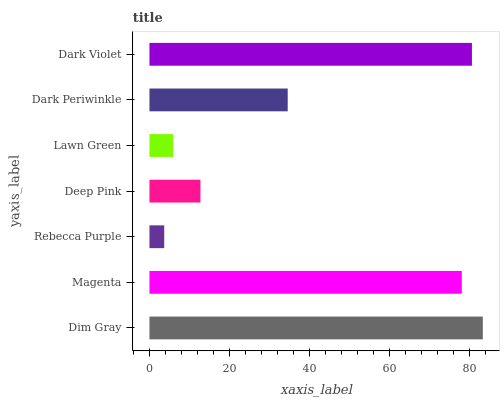Is Rebecca Purple the minimum?
Answer yes or no. Yes. Is Dim Gray the maximum?
Answer yes or no. Yes. Is Magenta the minimum?
Answer yes or no. No. Is Magenta the maximum?
Answer yes or no. No. Is Dim Gray greater than Magenta?
Answer yes or no. Yes. Is Magenta less than Dim Gray?
Answer yes or no. Yes. Is Magenta greater than Dim Gray?
Answer yes or no. No. Is Dim Gray less than Magenta?
Answer yes or no. No. Is Dark Periwinkle the high median?
Answer yes or no. Yes. Is Dark Periwinkle the low median?
Answer yes or no. Yes. Is Lawn Green the high median?
Answer yes or no. No. Is Dark Violet the low median?
Answer yes or no. No. 